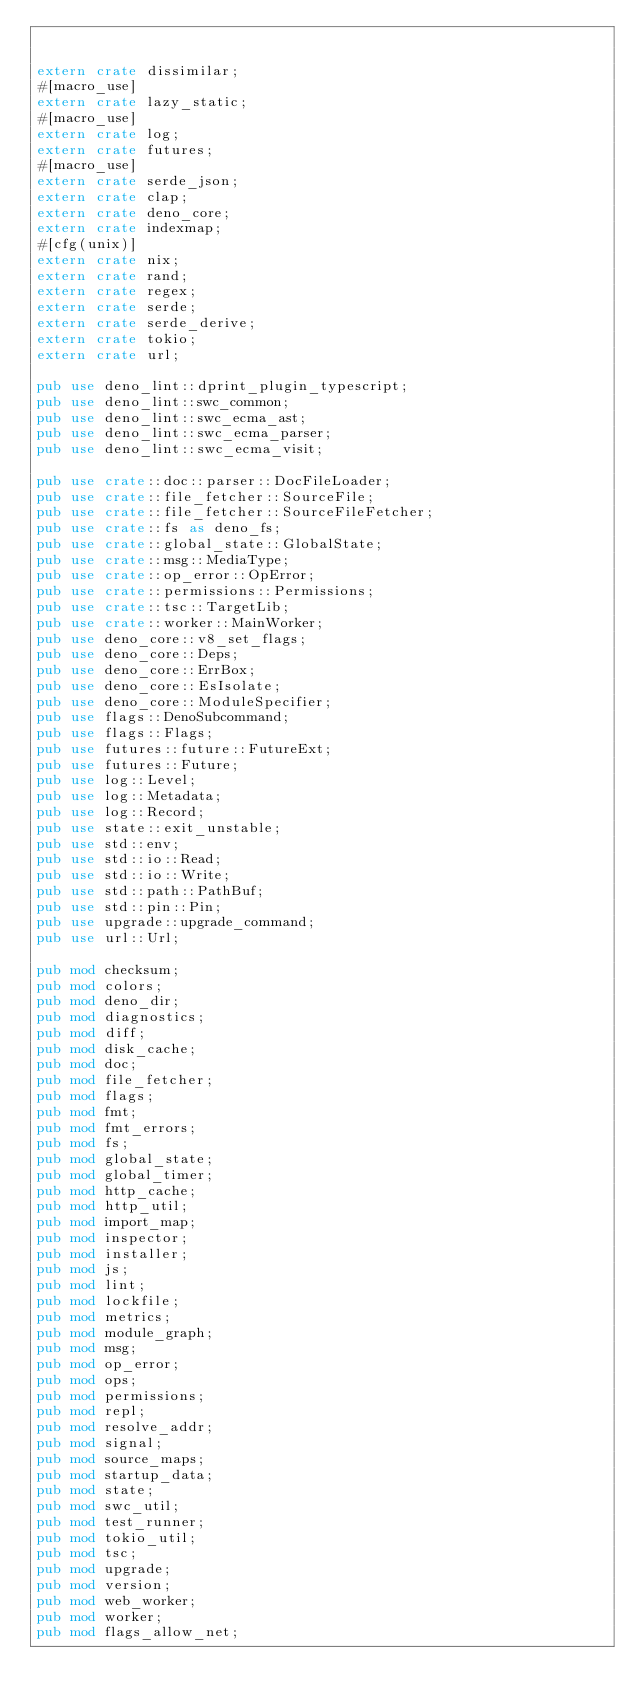Convert code to text. <code><loc_0><loc_0><loc_500><loc_500><_Rust_>

extern crate dissimilar;
#[macro_use]
extern crate lazy_static;
#[macro_use]
extern crate log;
extern crate futures;
#[macro_use]
extern crate serde_json;
extern crate clap;
extern crate deno_core;
extern crate indexmap;
#[cfg(unix)]
extern crate nix;
extern crate rand;
extern crate regex;
extern crate serde;
extern crate serde_derive;
extern crate tokio;
extern crate url;

pub use deno_lint::dprint_plugin_typescript;
pub use deno_lint::swc_common;
pub use deno_lint::swc_ecma_ast;
pub use deno_lint::swc_ecma_parser;
pub use deno_lint::swc_ecma_visit;

pub use crate::doc::parser::DocFileLoader;
pub use crate::file_fetcher::SourceFile;
pub use crate::file_fetcher::SourceFileFetcher;
pub use crate::fs as deno_fs;
pub use crate::global_state::GlobalState;
pub use crate::msg::MediaType;
pub use crate::op_error::OpError;
pub use crate::permissions::Permissions;
pub use crate::tsc::TargetLib;
pub use crate::worker::MainWorker;
pub use deno_core::v8_set_flags;
pub use deno_core::Deps;
pub use deno_core::ErrBox;
pub use deno_core::EsIsolate;
pub use deno_core::ModuleSpecifier;
pub use flags::DenoSubcommand;
pub use flags::Flags;
pub use futures::future::FutureExt;
pub use futures::Future;
pub use log::Level;
pub use log::Metadata;
pub use log::Record;
pub use state::exit_unstable;
pub use std::env;
pub use std::io::Read;
pub use std::io::Write;
pub use std::path::PathBuf;
pub use std::pin::Pin;
pub use upgrade::upgrade_command;
pub use url::Url;

pub mod checksum;
pub mod colors;
pub mod deno_dir;
pub mod diagnostics;
pub mod diff;
pub mod disk_cache;
pub mod doc;
pub mod file_fetcher;
pub mod flags;
pub mod fmt;
pub mod fmt_errors;
pub mod fs;
pub mod global_state;
pub mod global_timer;
pub mod http_cache;
pub mod http_util;
pub mod import_map;
pub mod inspector;
pub mod installer;
pub mod js;
pub mod lint;
pub mod lockfile;
pub mod metrics;
pub mod module_graph;
pub mod msg;
pub mod op_error;
pub mod ops;
pub mod permissions;
pub mod repl;
pub mod resolve_addr;
pub mod signal;
pub mod source_maps;
pub mod startup_data;
pub mod state;
pub mod swc_util;
pub mod test_runner;
pub mod tokio_util;
pub mod tsc;
pub mod upgrade;
pub mod version;
pub mod web_worker;
pub mod worker;
pub mod flags_allow_net;</code> 